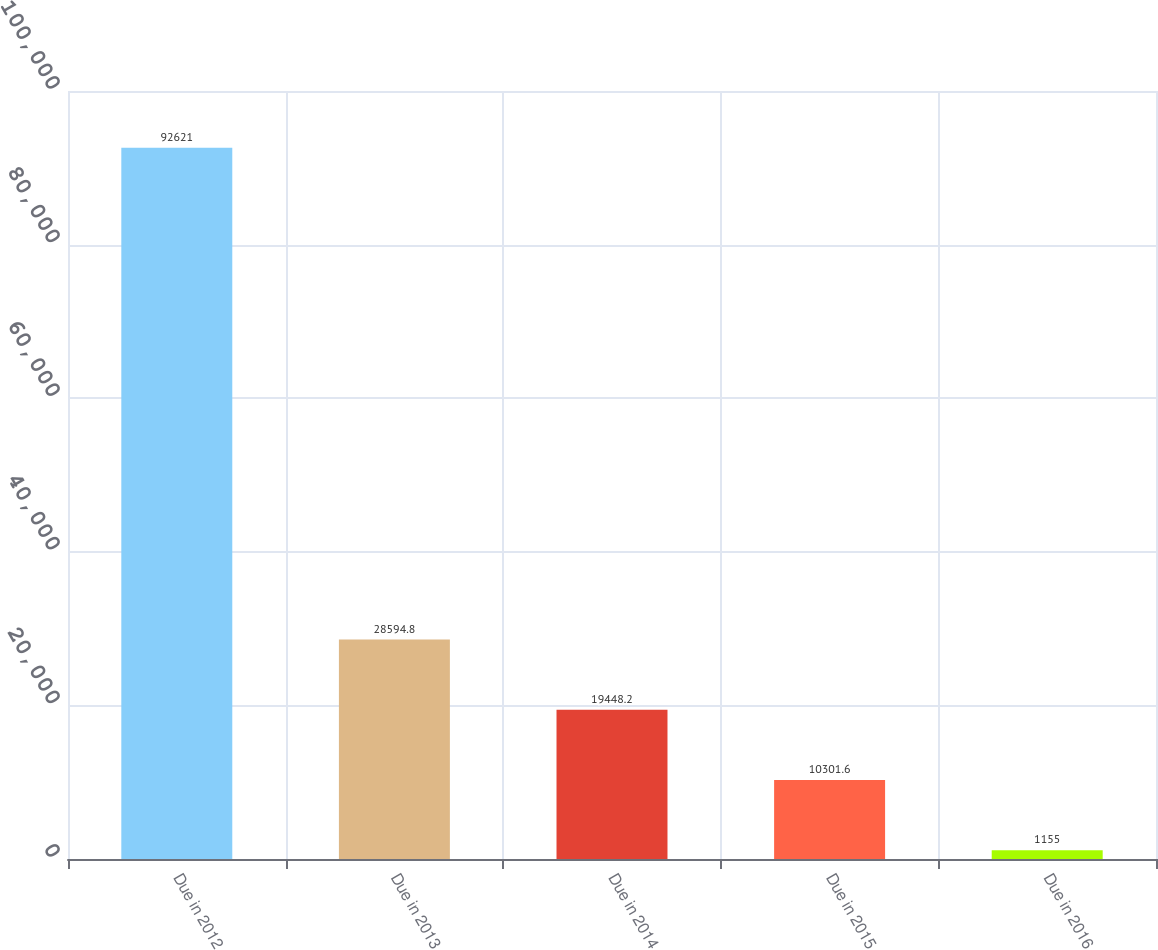Convert chart. <chart><loc_0><loc_0><loc_500><loc_500><bar_chart><fcel>Due in 2012<fcel>Due in 2013<fcel>Due in 2014<fcel>Due in 2015<fcel>Due in 2016<nl><fcel>92621<fcel>28594.8<fcel>19448.2<fcel>10301.6<fcel>1155<nl></chart> 